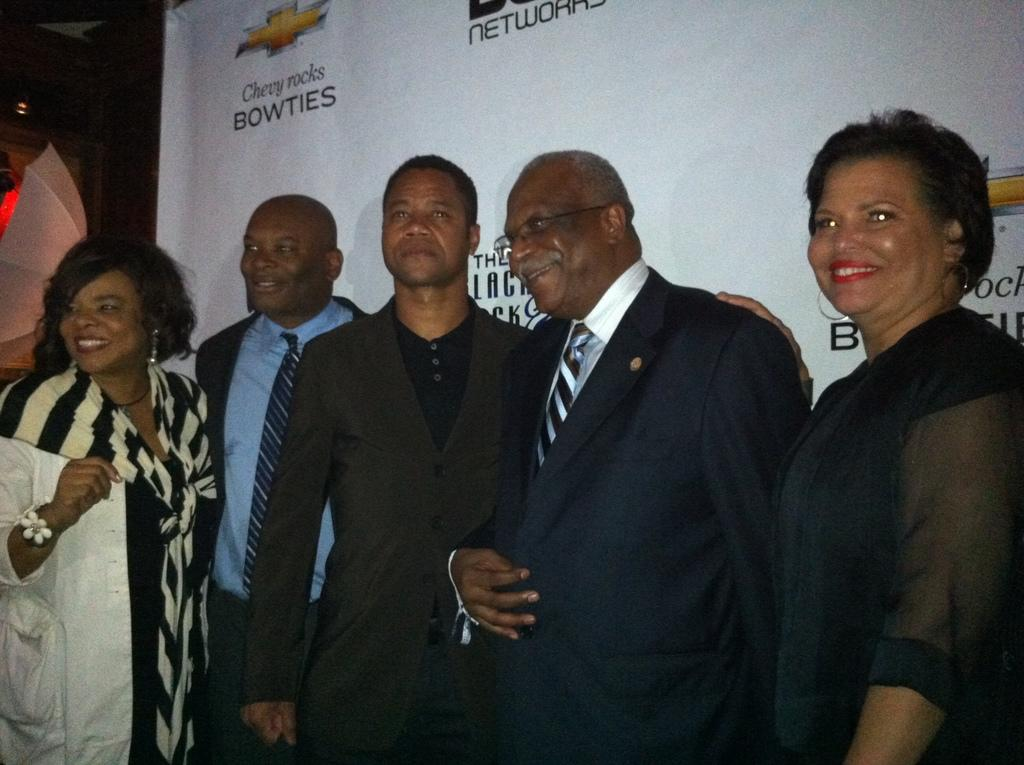What is happening in the foreground of the image? There is a group of people in the foreground of the image. What is the mood or expression of the people in the image? The people are smiling in the image. How are the people positioned in the image? The people are standing in the image. What can be seen in the background of the image? There is a banner and other objects visible in the background of the image. What year is depicted in the image? There is no specific year mentioned or depicted in the image. What town is the image taken in? The location of the image is not mentioned or identifiable from the provided facts. 